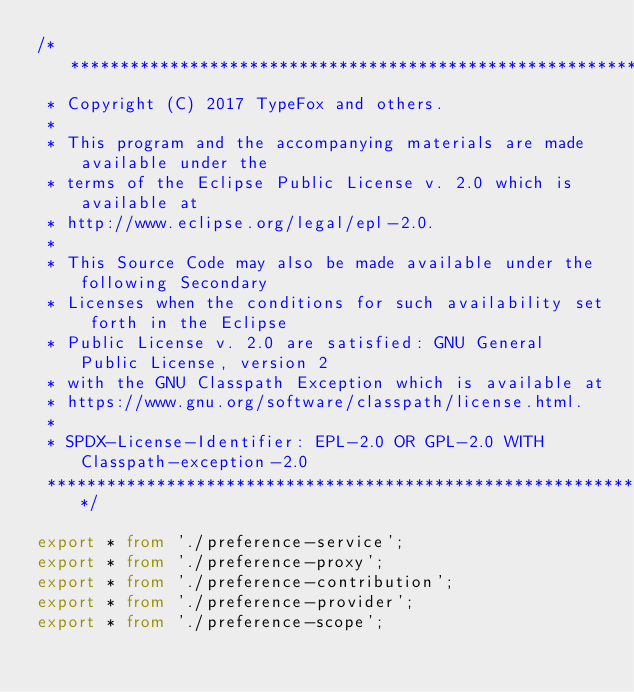Convert code to text. <code><loc_0><loc_0><loc_500><loc_500><_TypeScript_>/********************************************************************************
 * Copyright (C) 2017 TypeFox and others.
 *
 * This program and the accompanying materials are made available under the
 * terms of the Eclipse Public License v. 2.0 which is available at
 * http://www.eclipse.org/legal/epl-2.0.
 *
 * This Source Code may also be made available under the following Secondary
 * Licenses when the conditions for such availability set forth in the Eclipse
 * Public License v. 2.0 are satisfied: GNU General Public License, version 2
 * with the GNU Classpath Exception which is available at
 * https://www.gnu.org/software/classpath/license.html.
 *
 * SPDX-License-Identifier: EPL-2.0 OR GPL-2.0 WITH Classpath-exception-2.0
 ********************************************************************************/

export * from './preference-service';
export * from './preference-proxy';
export * from './preference-contribution';
export * from './preference-provider';
export * from './preference-scope';
</code> 